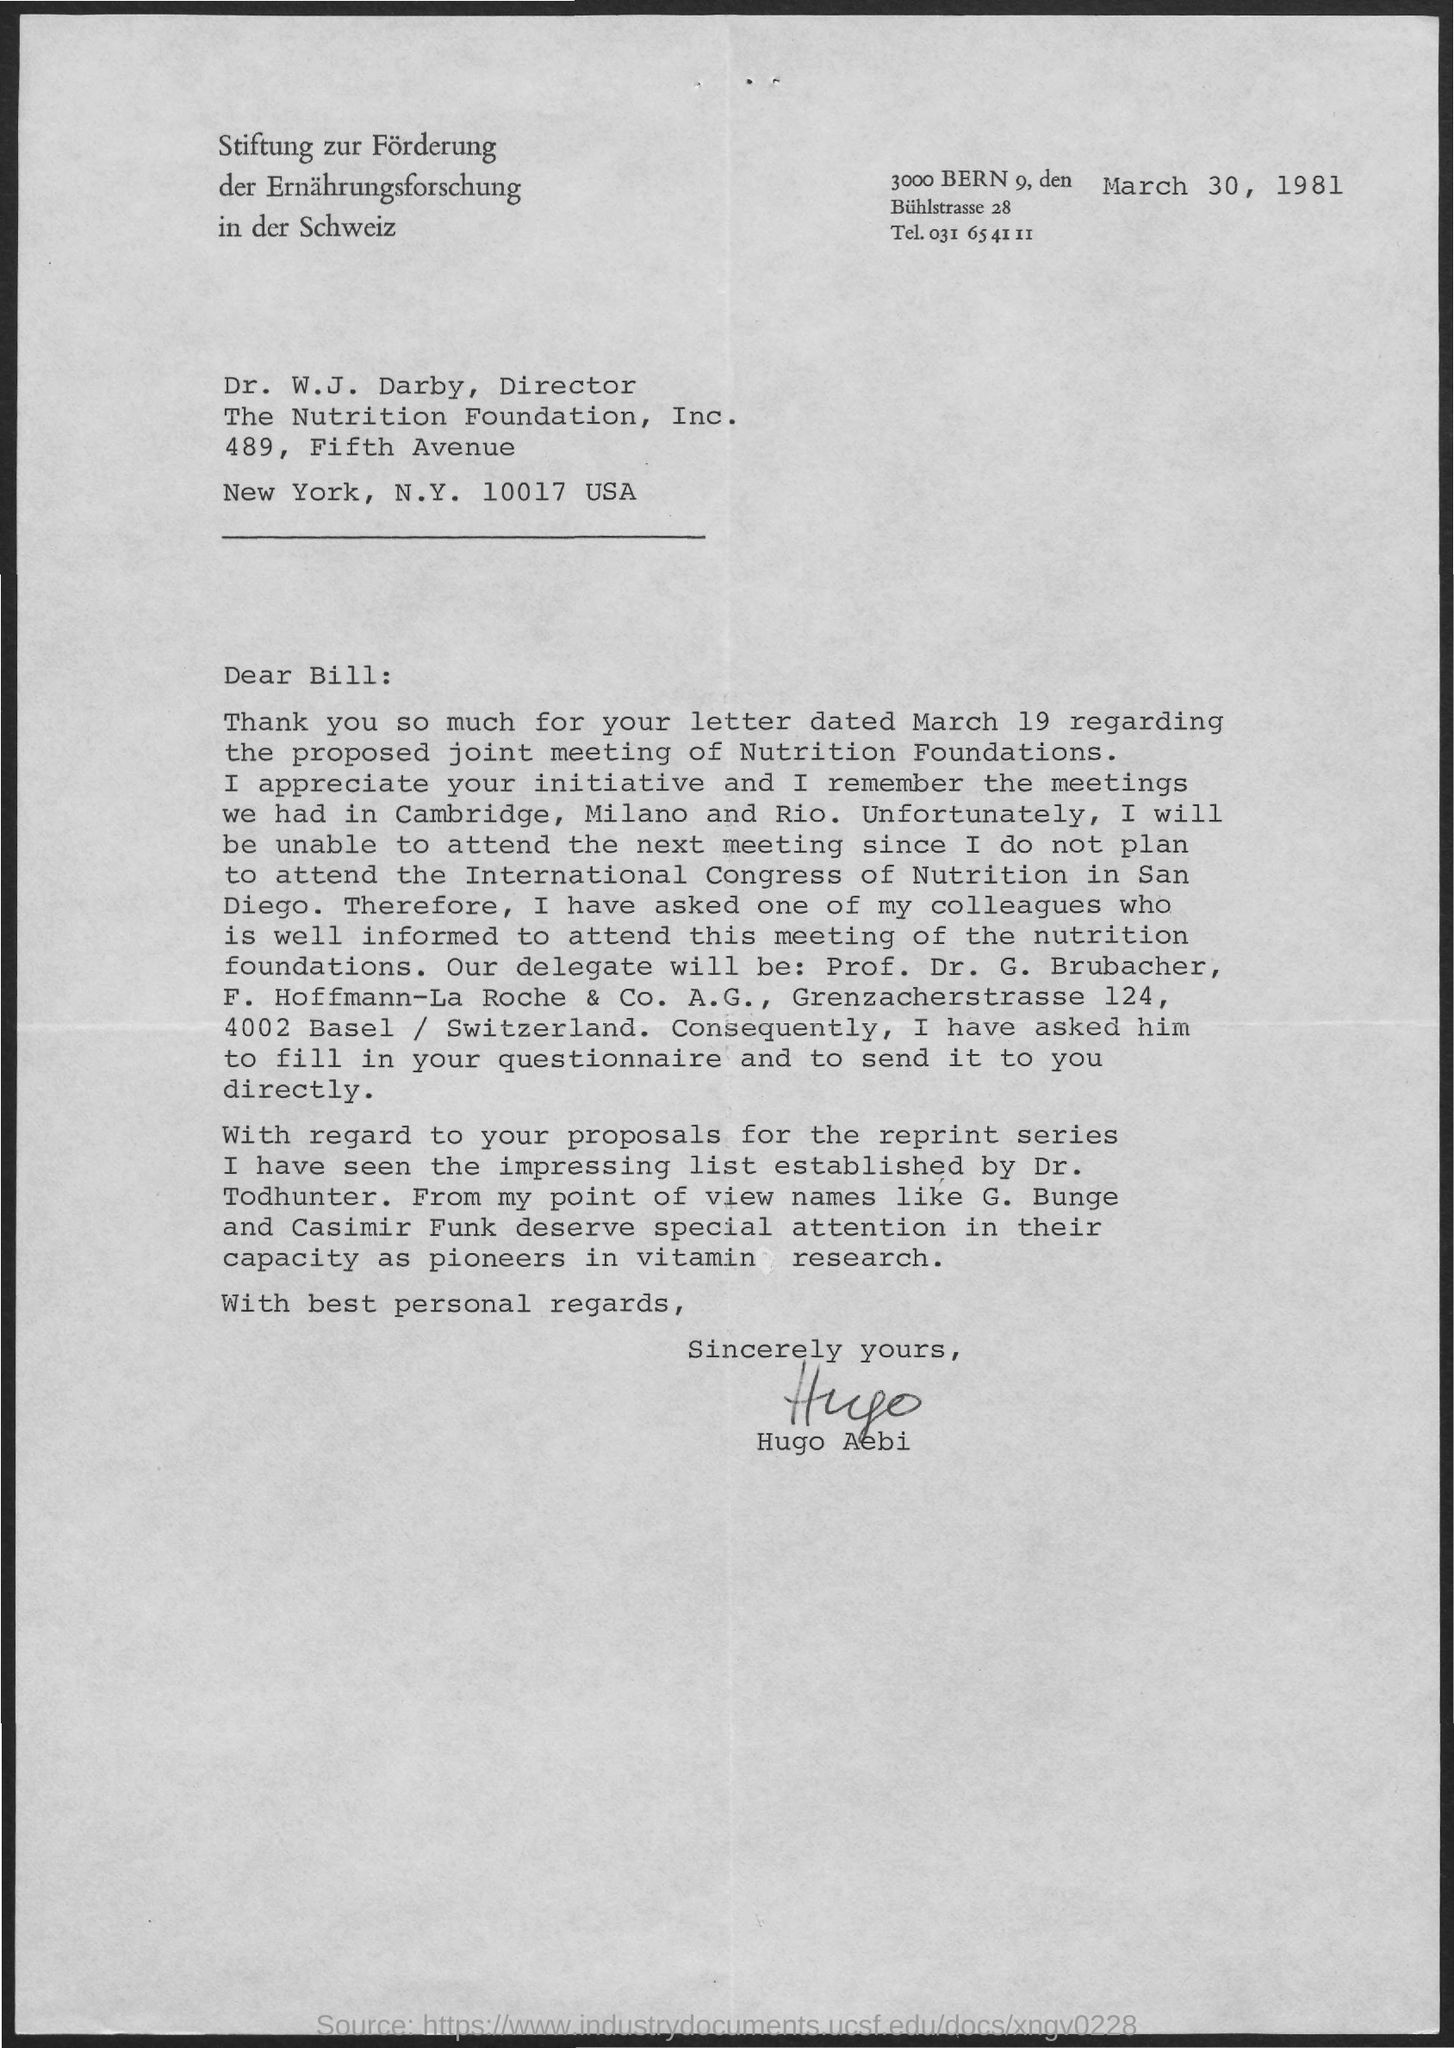When is the Memorandum dated on ?
Give a very brief answer. March 30, 1981. 